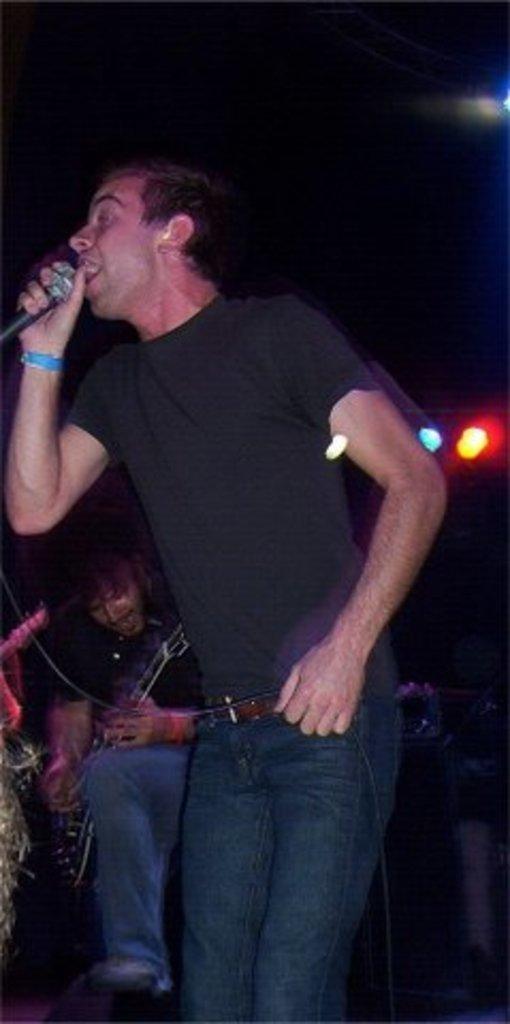How would you summarize this image in a sentence or two? In this picture we can see a man who is holding a mike with his hand. Here we can see a person who is playing guitar. And these are the lights. 